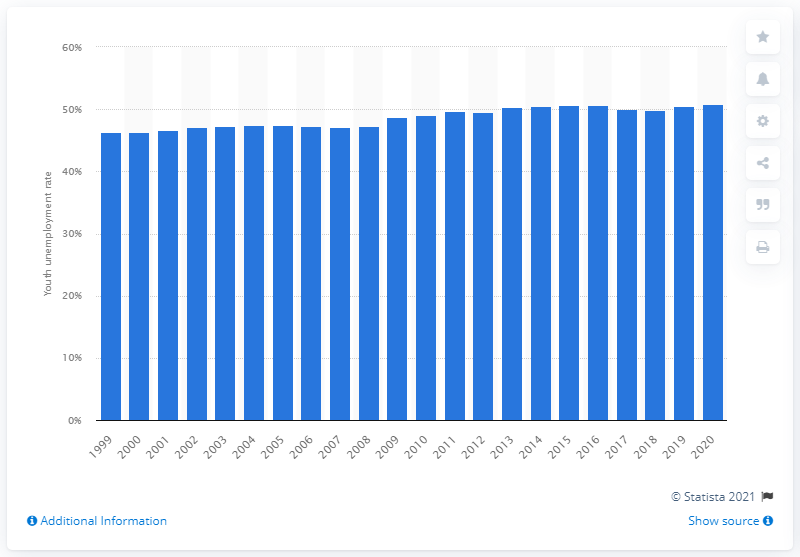Highlight a few significant elements in this photo. The youth unemployment rate in Libya in 2020 was 50.9%. 